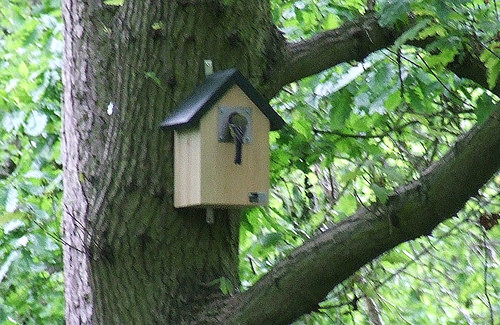<image>
Is there a house on the tree? Yes. Looking at the image, I can see the house is positioned on top of the tree, with the tree providing support. 